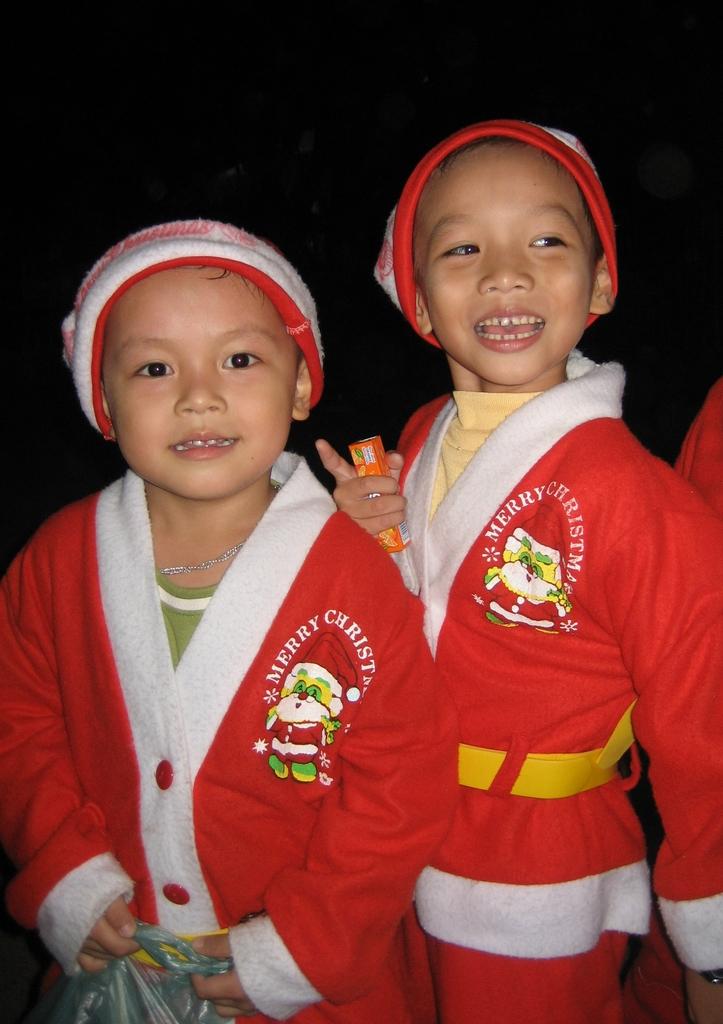What does it say above the santa logo?
Keep it short and to the point. Merry christmas. What is on the first boys robe?
Offer a very short reply. Merry christmas. 